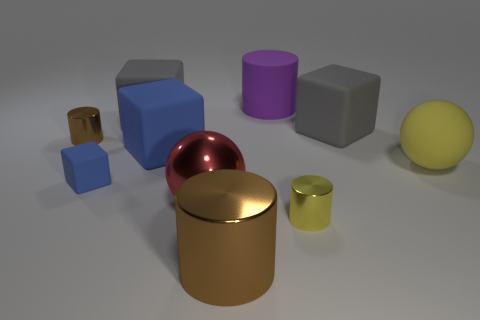Subtract all red spheres. How many gray blocks are left? 2 Subtract all tiny cubes. How many cubes are left? 3 Subtract all yellow cylinders. How many cylinders are left? 3 Subtract all green cylinders. Subtract all cyan blocks. How many cylinders are left? 4 Subtract all cylinders. How many objects are left? 6 Subtract 0 blue balls. How many objects are left? 10 Subtract all blue matte cubes. Subtract all tiny rubber cubes. How many objects are left? 7 Add 8 purple matte cylinders. How many purple matte cylinders are left? 9 Add 2 tiny metallic objects. How many tiny metallic objects exist? 4 